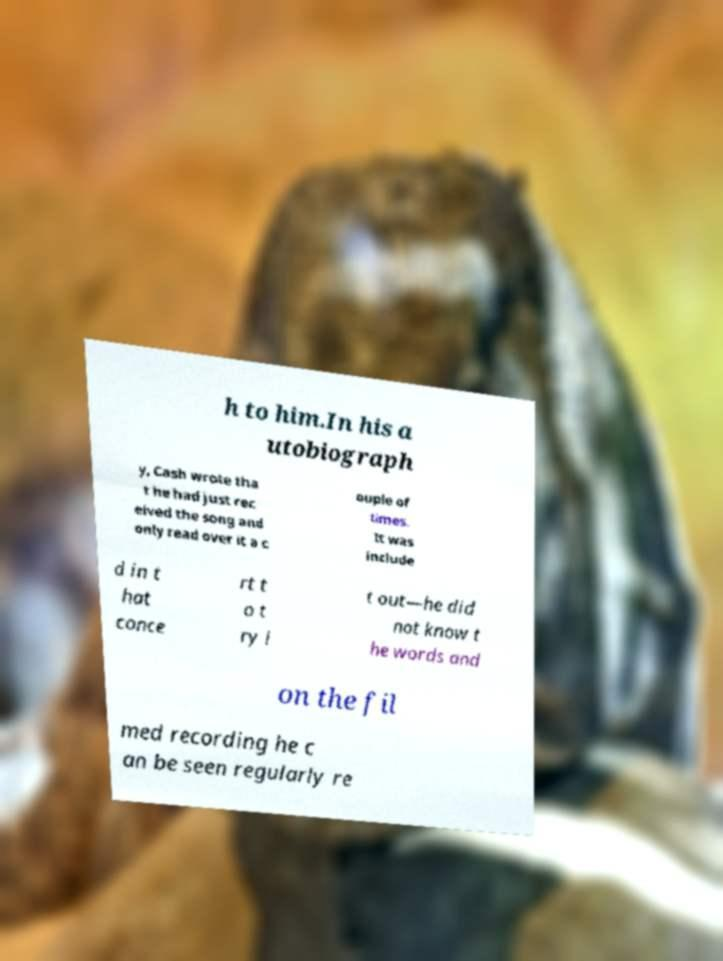Can you accurately transcribe the text from the provided image for me? h to him.In his a utobiograph y, Cash wrote tha t he had just rec eived the song and only read over it a c ouple of times. It was include d in t hat conce rt t o t ry i t out—he did not know t he words and on the fil med recording he c an be seen regularly re 